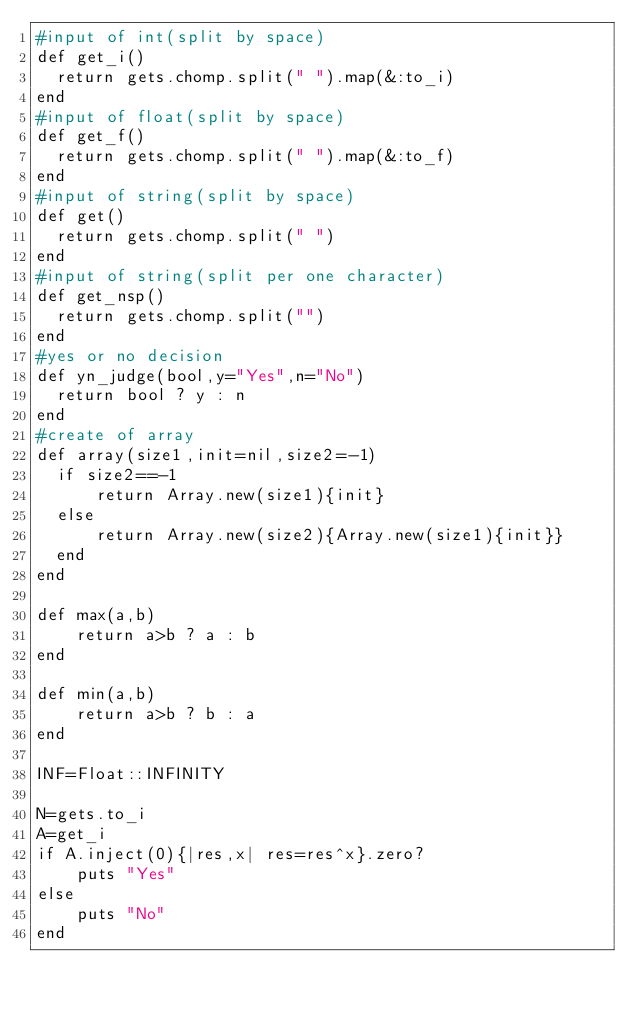Convert code to text. <code><loc_0><loc_0><loc_500><loc_500><_Ruby_>#input of int(split by space)
def get_i()
  return gets.chomp.split(" ").map(&:to_i)
end
#input of float(split by space)
def get_f()
  return gets.chomp.split(" ").map(&:to_f)
end
#input of string(split by space)
def get()
  return gets.chomp.split(" ")
end
#input of string(split per one character)
def get_nsp()
  return gets.chomp.split("")
end
#yes or no decision
def yn_judge(bool,y="Yes",n="No")
  return bool ? y : n 
end
#create of array
def array(size1,init=nil,size2=-1)
  if size2==-1
      return Array.new(size1){init}
  else
      return Array.new(size2){Array.new(size1){init}}
  end
end

def max(a,b)
    return a>b ? a : b
end

def min(a,b)
    return a>b ? b : a
end

INF=Float::INFINITY

N=gets.to_i
A=get_i
if A.inject(0){|res,x| res=res^x}.zero?
    puts "Yes"
else
    puts "No"
end</code> 